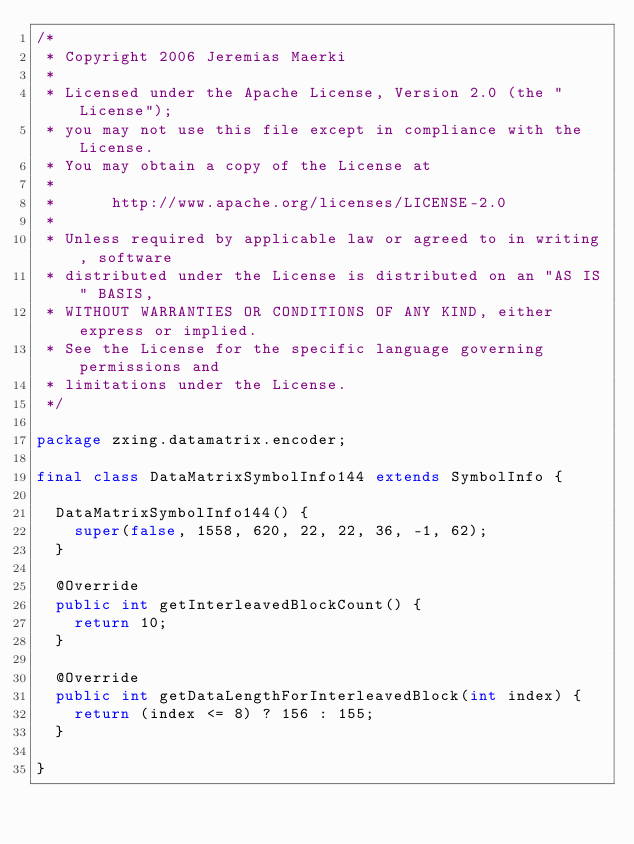Convert code to text. <code><loc_0><loc_0><loc_500><loc_500><_Java_>/*
 * Copyright 2006 Jeremias Maerki
 *
 * Licensed under the Apache License, Version 2.0 (the "License");
 * you may not use this file except in compliance with the License.
 * You may obtain a copy of the License at
 *
 *      http://www.apache.org/licenses/LICENSE-2.0
 *
 * Unless required by applicable law or agreed to in writing, software
 * distributed under the License is distributed on an "AS IS" BASIS,
 * WITHOUT WARRANTIES OR CONDITIONS OF ANY KIND, either express or implied.
 * See the License for the specific language governing permissions and
 * limitations under the License.
 */

package zxing.datamatrix.encoder;

final class DataMatrixSymbolInfo144 extends SymbolInfo {

  DataMatrixSymbolInfo144() {
    super(false, 1558, 620, 22, 22, 36, -1, 62);
  }

  @Override
  public int getInterleavedBlockCount() {
    return 10;
  }

  @Override
  public int getDataLengthForInterleavedBlock(int index) {
    return (index <= 8) ? 156 : 155;
  }

}
</code> 